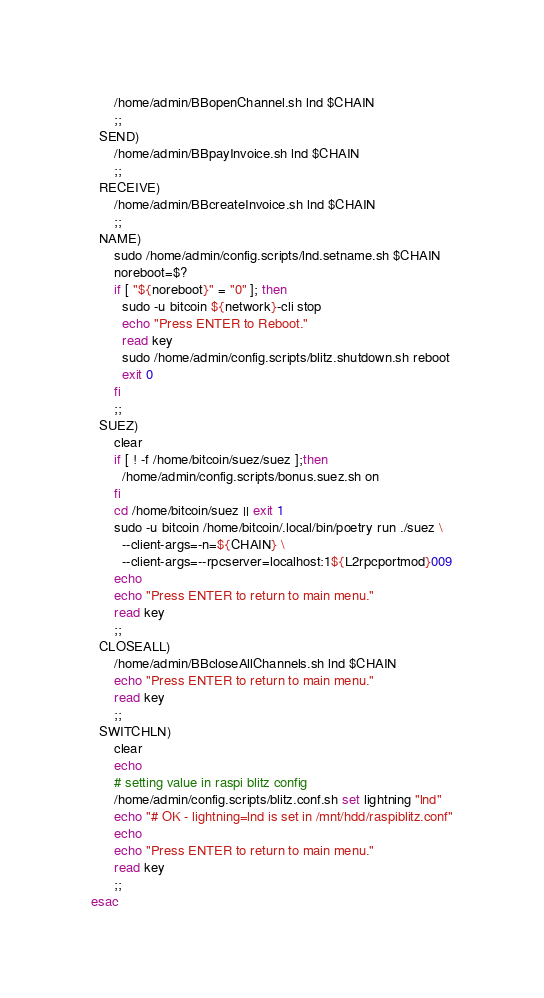Convert code to text. <code><loc_0><loc_0><loc_500><loc_500><_Bash_>      /home/admin/BBopenChannel.sh lnd $CHAIN
      ;;
  SEND)
      /home/admin/BBpayInvoice.sh lnd $CHAIN
      ;;
  RECEIVE)
      /home/admin/BBcreateInvoice.sh lnd $CHAIN
      ;;
  NAME)
      sudo /home/admin/config.scripts/lnd.setname.sh $CHAIN
      noreboot=$?
      if [ "${noreboot}" = "0" ]; then
        sudo -u bitcoin ${network}-cli stop
        echo "Press ENTER to Reboot."
        read key
        sudo /home/admin/config.scripts/blitz.shutdown.sh reboot
        exit 0
      fi
      ;;
  SUEZ)
      clear
      if [ ! -f /home/bitcoin/suez/suez ];then
        /home/admin/config.scripts/bonus.suez.sh on
      fi
      cd /home/bitcoin/suez || exit 1 
      sudo -u bitcoin /home/bitcoin/.local/bin/poetry run ./suez \
        --client-args=-n=${CHAIN} \
        --client-args=--rpcserver=localhost:1${L2rpcportmod}009
      echo
      echo "Press ENTER to return to main menu."
      read key
      ;;
  CLOSEALL)
      /home/admin/BBcloseAllChannels.sh lnd $CHAIN
      echo "Press ENTER to return to main menu."
      read key
      ;;
  SWITCHLN)
      clear 
      echo
      # setting value in raspi blitz config
      /home/admin/config.scripts/blitz.conf.sh set lightning "lnd"
      echo "# OK - lightning=lnd is set in /mnt/hdd/raspiblitz.conf"
      echo
      echo "Press ENTER to return to main menu."
      read key
      ;;
esac
</code> 